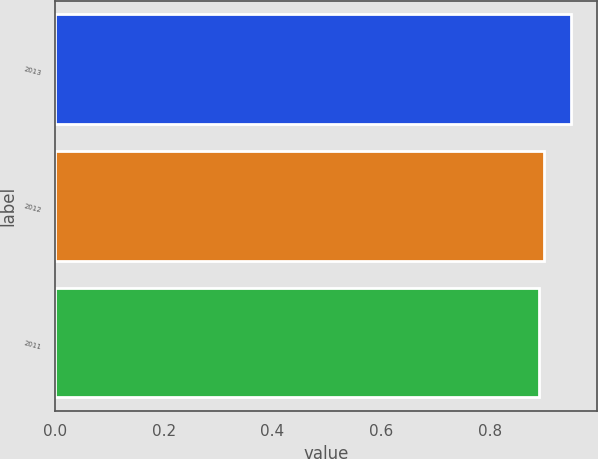Convert chart. <chart><loc_0><loc_0><loc_500><loc_500><bar_chart><fcel>2013<fcel>2012<fcel>2011<nl><fcel>0.95<fcel>0.9<fcel>0.89<nl></chart> 